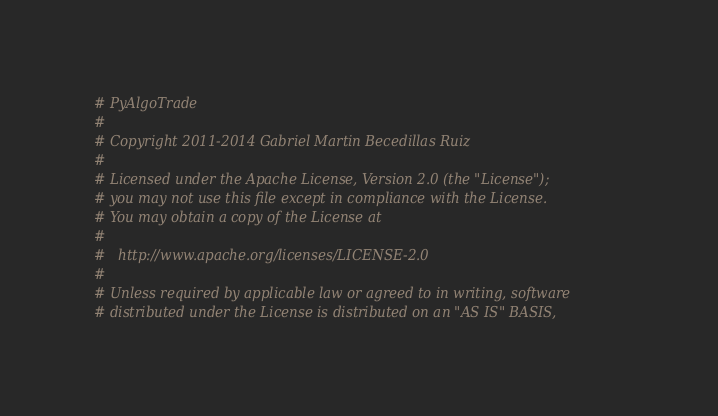Convert code to text. <code><loc_0><loc_0><loc_500><loc_500><_Python_># PyAlgoTrade
#
# Copyright 2011-2014 Gabriel Martin Becedillas Ruiz
#
# Licensed under the Apache License, Version 2.0 (the "License");
# you may not use this file except in compliance with the License.
# You may obtain a copy of the License at
#
#   http://www.apache.org/licenses/LICENSE-2.0
#
# Unless required by applicable law or agreed to in writing, software
# distributed under the License is distributed on an "AS IS" BASIS,</code> 